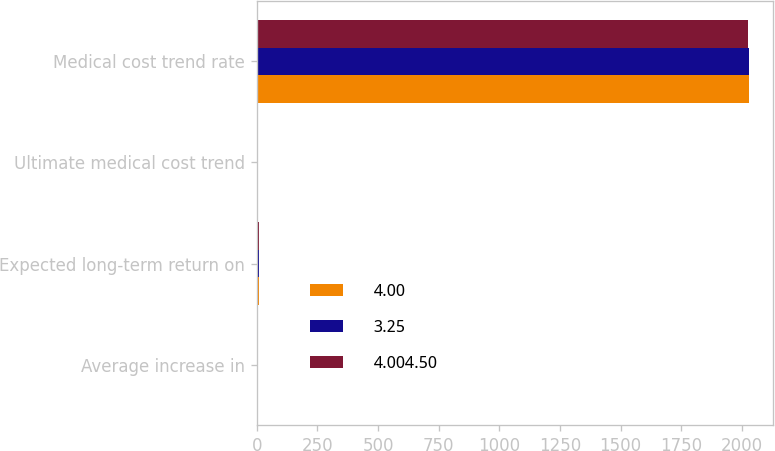<chart> <loc_0><loc_0><loc_500><loc_500><stacked_bar_chart><ecel><fcel>Average increase in<fcel>Expected long-term return on<fcel>Ultimate medical cost trend<fcel>Medical cost trend rate<nl><fcel>4.00<fcel>3.5<fcel>8<fcel>3.5<fcel>2028<nl><fcel>3.25<fcel>3.5<fcel>8<fcel>3.5<fcel>2028<nl><fcel>4.004.50<fcel>3.5<fcel>8<fcel>3.5<fcel>2027<nl></chart> 